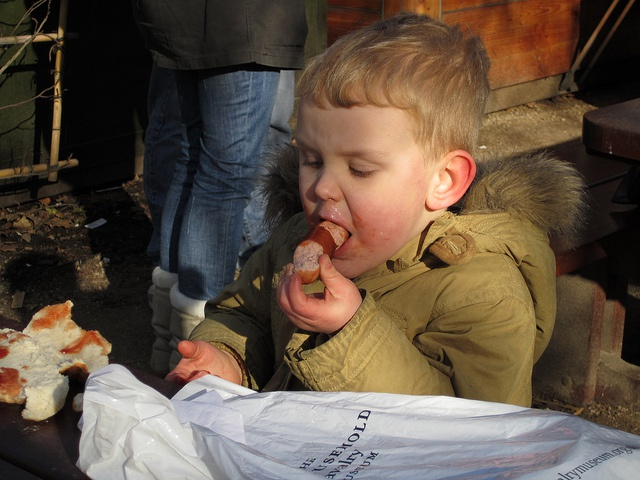Describe the objects in this image and their specific colors. I can see people in black, olive, gray, and tan tones, people in black, gray, and darkblue tones, and hot dog in black, maroon, gray, tan, and brown tones in this image. 